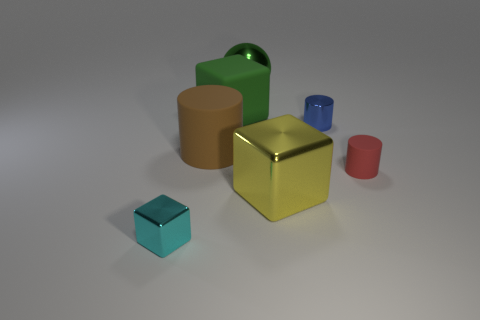Subtract all large cubes. How many cubes are left? 1 Subtract 1 cylinders. How many cylinders are left? 2 Add 1 green matte balls. How many objects exist? 8 Subtract all blue blocks. Subtract all gray balls. How many blocks are left? 3 Subtract all balls. How many objects are left? 6 Subtract 0 yellow cylinders. How many objects are left? 7 Subtract all big purple metallic spheres. Subtract all green shiny things. How many objects are left? 6 Add 4 small rubber cylinders. How many small rubber cylinders are left? 5 Add 4 large green spheres. How many large green spheres exist? 5 